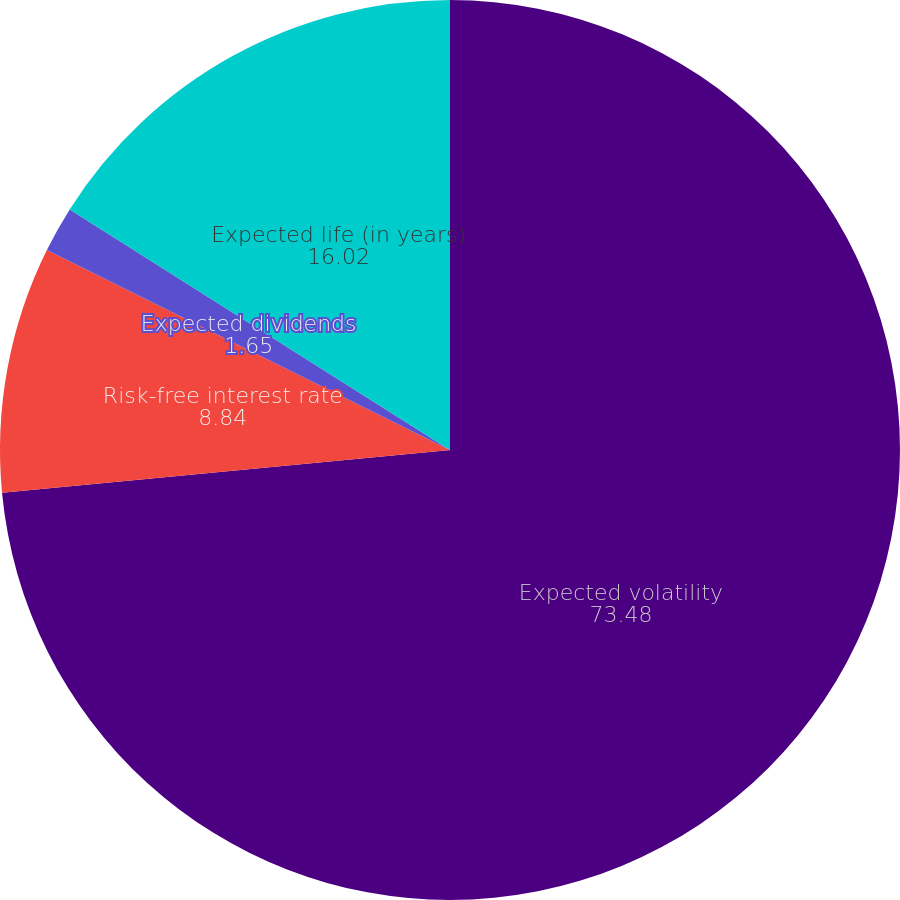<chart> <loc_0><loc_0><loc_500><loc_500><pie_chart><fcel>Expected volatility<fcel>Risk-free interest rate<fcel>Expected dividends<fcel>Expected life (in years)<nl><fcel>73.48%<fcel>8.84%<fcel>1.65%<fcel>16.02%<nl></chart> 